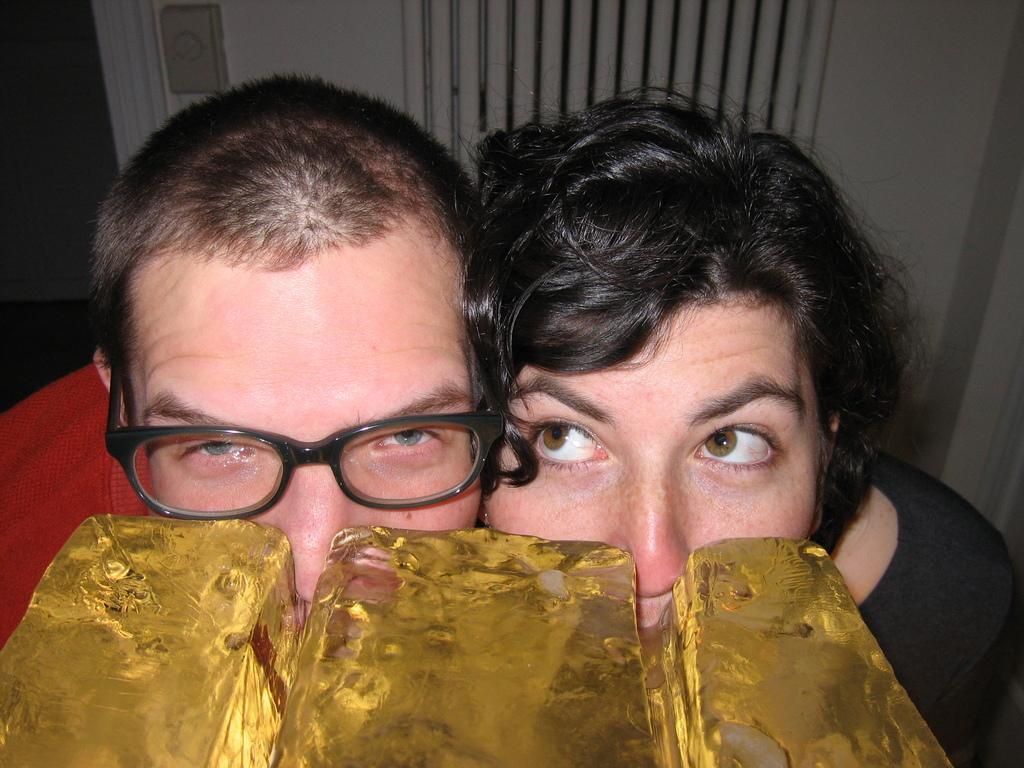How would you summarize this image in a sentence or two? In this image we can see two persons. One person wearing red t shirt and spectacles. One woman is wearing black t shirt. In the foreground we can see ice blocks. 